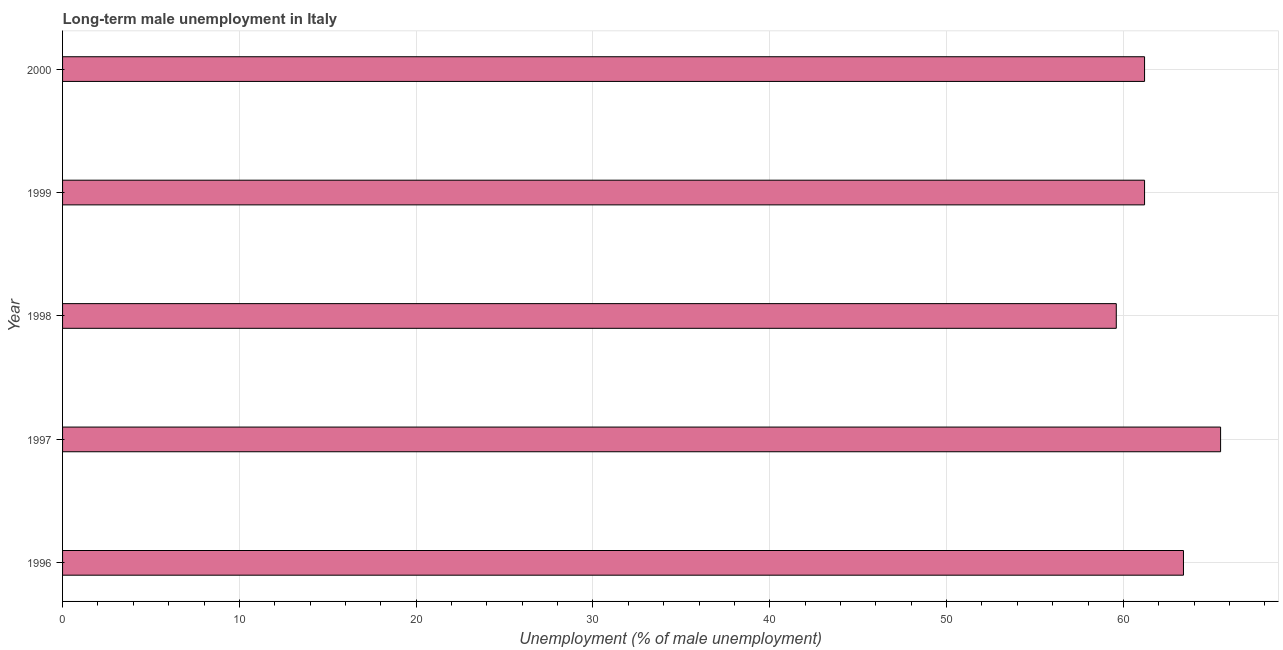Does the graph contain any zero values?
Provide a succinct answer. No. What is the title of the graph?
Make the answer very short. Long-term male unemployment in Italy. What is the label or title of the X-axis?
Ensure brevity in your answer.  Unemployment (% of male unemployment). What is the long-term male unemployment in 2000?
Your response must be concise. 61.2. Across all years, what is the maximum long-term male unemployment?
Keep it short and to the point. 65.5. Across all years, what is the minimum long-term male unemployment?
Your answer should be very brief. 59.6. What is the sum of the long-term male unemployment?
Make the answer very short. 310.9. What is the difference between the long-term male unemployment in 1997 and 2000?
Ensure brevity in your answer.  4.3. What is the average long-term male unemployment per year?
Offer a terse response. 62.18. What is the median long-term male unemployment?
Give a very brief answer. 61.2. Do a majority of the years between 1999 and 1998 (inclusive) have long-term male unemployment greater than 26 %?
Your answer should be very brief. No. What is the ratio of the long-term male unemployment in 1997 to that in 1999?
Offer a terse response. 1.07. Is the long-term male unemployment in 1996 less than that in 1998?
Your response must be concise. No. Is the sum of the long-term male unemployment in 1996 and 1997 greater than the maximum long-term male unemployment across all years?
Your answer should be very brief. Yes. Are all the bars in the graph horizontal?
Give a very brief answer. Yes. How many years are there in the graph?
Keep it short and to the point. 5. What is the difference between two consecutive major ticks on the X-axis?
Your answer should be very brief. 10. Are the values on the major ticks of X-axis written in scientific E-notation?
Keep it short and to the point. No. What is the Unemployment (% of male unemployment) of 1996?
Provide a short and direct response. 63.4. What is the Unemployment (% of male unemployment) of 1997?
Give a very brief answer. 65.5. What is the Unemployment (% of male unemployment) in 1998?
Provide a succinct answer. 59.6. What is the Unemployment (% of male unemployment) of 1999?
Ensure brevity in your answer.  61.2. What is the Unemployment (% of male unemployment) in 2000?
Your answer should be very brief. 61.2. What is the difference between the Unemployment (% of male unemployment) in 1996 and 1997?
Give a very brief answer. -2.1. What is the difference between the Unemployment (% of male unemployment) in 1996 and 2000?
Provide a short and direct response. 2.2. What is the difference between the Unemployment (% of male unemployment) in 1997 and 1998?
Provide a succinct answer. 5.9. What is the difference between the Unemployment (% of male unemployment) in 1998 and 1999?
Your answer should be compact. -1.6. What is the ratio of the Unemployment (% of male unemployment) in 1996 to that in 1997?
Provide a succinct answer. 0.97. What is the ratio of the Unemployment (% of male unemployment) in 1996 to that in 1998?
Make the answer very short. 1.06. What is the ratio of the Unemployment (% of male unemployment) in 1996 to that in 1999?
Keep it short and to the point. 1.04. What is the ratio of the Unemployment (% of male unemployment) in 1996 to that in 2000?
Ensure brevity in your answer.  1.04. What is the ratio of the Unemployment (% of male unemployment) in 1997 to that in 1998?
Make the answer very short. 1.1. What is the ratio of the Unemployment (% of male unemployment) in 1997 to that in 1999?
Make the answer very short. 1.07. What is the ratio of the Unemployment (% of male unemployment) in 1997 to that in 2000?
Offer a terse response. 1.07. What is the ratio of the Unemployment (% of male unemployment) in 1998 to that in 2000?
Your response must be concise. 0.97. What is the ratio of the Unemployment (% of male unemployment) in 1999 to that in 2000?
Your response must be concise. 1. 